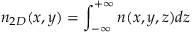<formula> <loc_0><loc_0><loc_500><loc_500>n _ { 2 D } ( x , y ) = \int _ { - \infty } ^ { + \infty } n ( x , y , z ) d z</formula> 